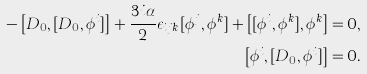Convert formula to latex. <formula><loc_0><loc_0><loc_500><loc_500>- \left [ D _ { 0 } , [ D _ { 0 } , \phi ^ { i } ] \right ] + \frac { 3 i \alpha } { 2 } \epsilon _ { i j k } [ \phi ^ { j } , \phi ^ { k } ] + \left [ [ \phi ^ { i } , \phi ^ { k } ] , \phi ^ { k } \right ] = 0 , \\ \quad \left [ \phi ^ { i } , [ D _ { 0 } , \phi ^ { i } ] \right ] = 0 .</formula> 